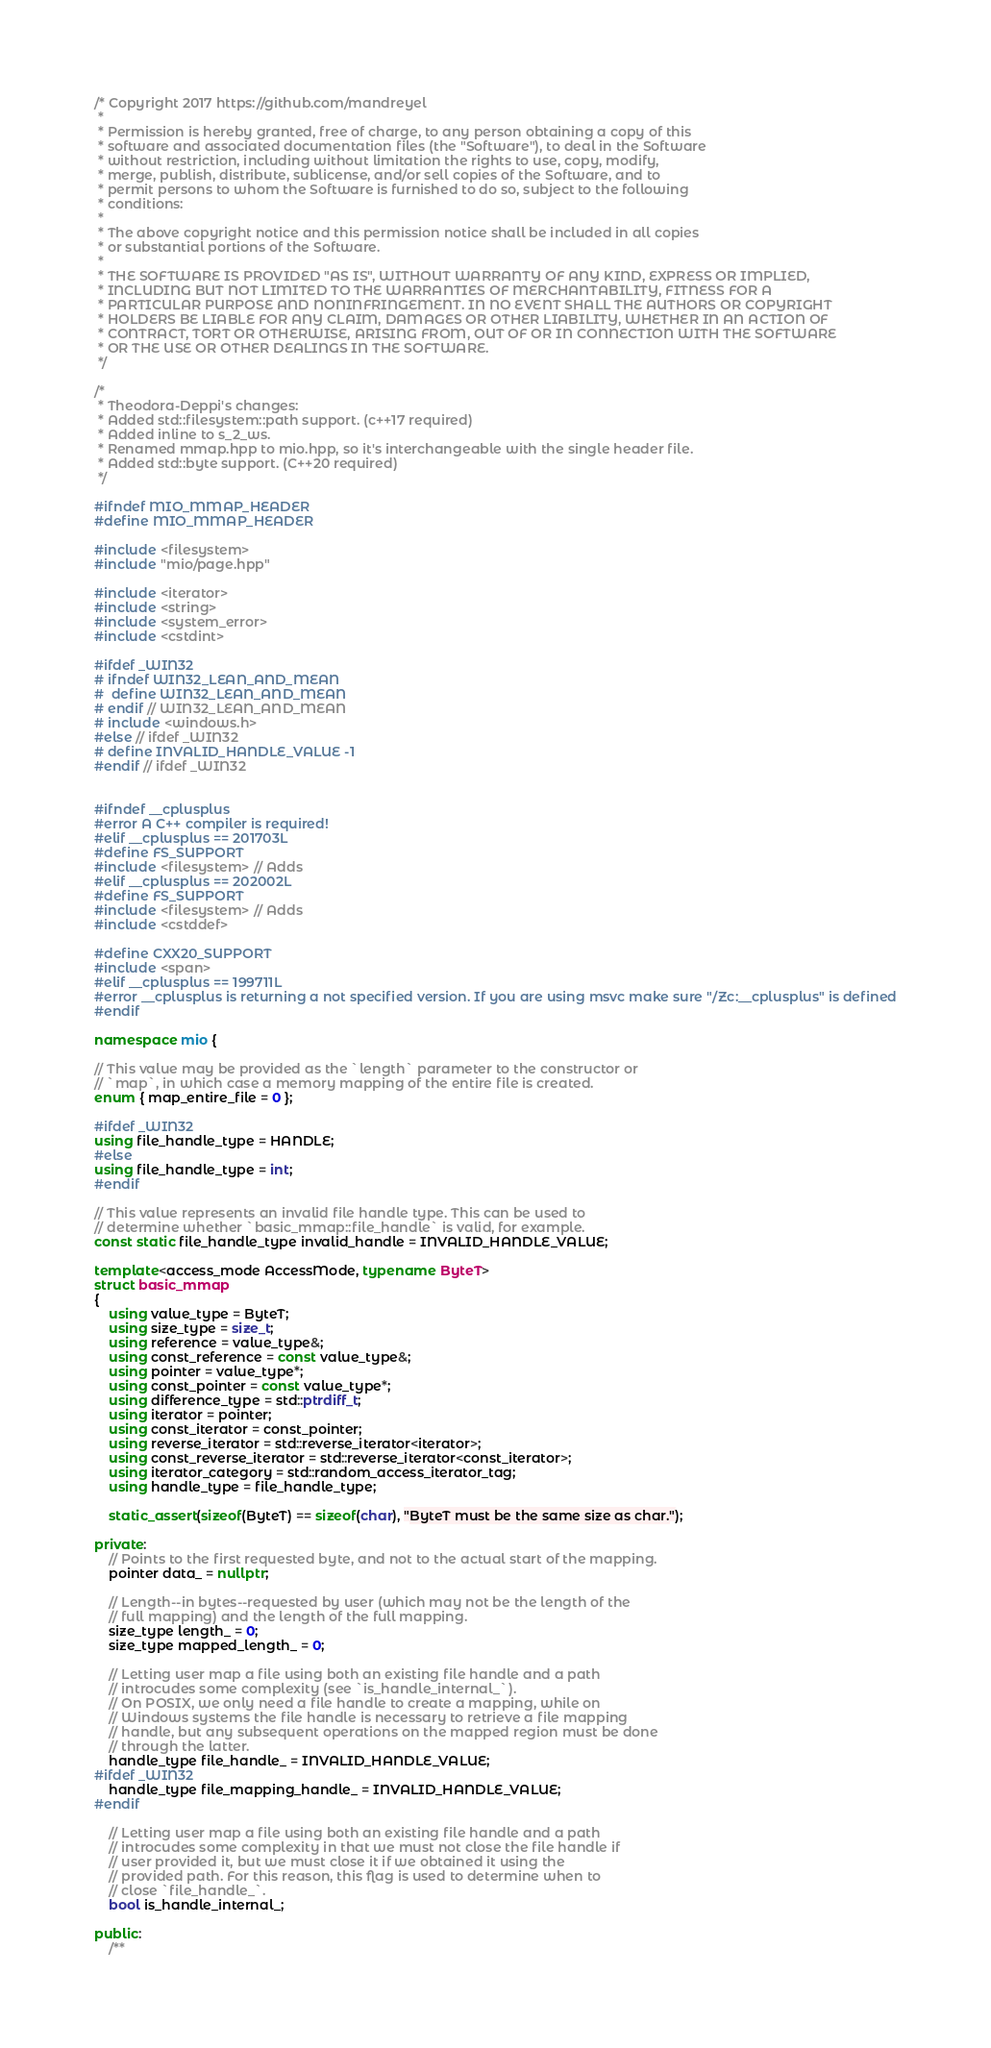Convert code to text. <code><loc_0><loc_0><loc_500><loc_500><_C++_>/* Copyright 2017 https://github.com/mandreyel
 *
 * Permission is hereby granted, free of charge, to any person obtaining a copy of this
 * software and associated documentation files (the "Software"), to deal in the Software
 * without restriction, including without limitation the rights to use, copy, modify,
 * merge, publish, distribute, sublicense, and/or sell copies of the Software, and to
 * permit persons to whom the Software is furnished to do so, subject to the following
 * conditions:
 *
 * The above copyright notice and this permission notice shall be included in all copies
 * or substantial portions of the Software.
 *
 * THE SOFTWARE IS PROVIDED "AS IS", WITHOUT WARRANTY OF ANY KIND, EXPRESS OR IMPLIED,
 * INCLUDING BUT NOT LIMITED TO THE WARRANTIES OF MERCHANTABILITY, FITNESS FOR A
 * PARTICULAR PURPOSE AND NONINFRINGEMENT. IN NO EVENT SHALL THE AUTHORS OR COPYRIGHT
 * HOLDERS BE LIABLE FOR ANY CLAIM, DAMAGES OR OTHER LIABILITY, WHETHER IN AN ACTION OF
 * CONTRACT, TORT OR OTHERWISE, ARISING FROM, OUT OF OR IN CONNECTION WITH THE SOFTWARE
 * OR THE USE OR OTHER DEALINGS IN THE SOFTWARE.
 */

/*
 * Theodora-Deppi's changes:
 * Added std::filesystem::path support. (c++17 required)
 * Added inline to s_2_ws.
 * Renamed mmap.hpp to mio.hpp, so it's interchangeable with the single header file.
 * Added std::byte support. (C++20 required)
 */

#ifndef MIO_MMAP_HEADER
#define MIO_MMAP_HEADER

#include <filesystem>
#include "mio/page.hpp"

#include <iterator>
#include <string>
#include <system_error>
#include <cstdint>

#ifdef _WIN32
# ifndef WIN32_LEAN_AND_MEAN
#  define WIN32_LEAN_AND_MEAN
# endif // WIN32_LEAN_AND_MEAN
# include <windows.h>
#else // ifdef _WIN32
# define INVALID_HANDLE_VALUE -1
#endif // ifdef _WIN32


#ifndef __cplusplus
#error A C++ compiler is required!
#elif __cplusplus == 201703L
#define FS_SUPPORT
#include <filesystem> // Adds
#elif __cplusplus == 202002L
#define FS_SUPPORT
#include <filesystem> // Adds
#include <cstddef>

#define CXX20_SUPPORT
#include <span>
#elif __cplusplus == 199711L
#error __cplusplus is returning a not specified version. If you are using msvc make sure "/Zc:__cplusplus" is defined
#endif

namespace mio {

// This value may be provided as the `length` parameter to the constructor or
// `map`, in which case a memory mapping of the entire file is created.
enum { map_entire_file = 0 };

#ifdef _WIN32
using file_handle_type = HANDLE;
#else
using file_handle_type = int;
#endif

// This value represents an invalid file handle type. This can be used to
// determine whether `basic_mmap::file_handle` is valid, for example.
const static file_handle_type invalid_handle = INVALID_HANDLE_VALUE;

template<access_mode AccessMode, typename ByteT>
struct basic_mmap
{
    using value_type = ByteT;
    using size_type = size_t;
    using reference = value_type&;
    using const_reference = const value_type&;
    using pointer = value_type*;
    using const_pointer = const value_type*;
    using difference_type = std::ptrdiff_t;
    using iterator = pointer;
    using const_iterator = const_pointer;
    using reverse_iterator = std::reverse_iterator<iterator>;
    using const_reverse_iterator = std::reverse_iterator<const_iterator>;
    using iterator_category = std::random_access_iterator_tag;
    using handle_type = file_handle_type;

    static_assert(sizeof(ByteT) == sizeof(char), "ByteT must be the same size as char.");

private:
    // Points to the first requested byte, and not to the actual start of the mapping.
    pointer data_ = nullptr;

    // Length--in bytes--requested by user (which may not be the length of the
    // full mapping) and the length of the full mapping.
    size_type length_ = 0;
    size_type mapped_length_ = 0;

    // Letting user map a file using both an existing file handle and a path
    // introcudes some complexity (see `is_handle_internal_`).
    // On POSIX, we only need a file handle to create a mapping, while on
    // Windows systems the file handle is necessary to retrieve a file mapping
    // handle, but any subsequent operations on the mapped region must be done
    // through the latter.
    handle_type file_handle_ = INVALID_HANDLE_VALUE;
#ifdef _WIN32
    handle_type file_mapping_handle_ = INVALID_HANDLE_VALUE;
#endif

    // Letting user map a file using both an existing file handle and a path
    // introcudes some complexity in that we must not close the file handle if
    // user provided it, but we must close it if we obtained it using the
    // provided path. For this reason, this flag is used to determine when to
    // close `file_handle_`.
    bool is_handle_internal_;

public:
    /**</code> 